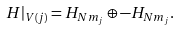<formula> <loc_0><loc_0><loc_500><loc_500>H | _ { V ( j ) } = H _ { N m _ { j } } \oplus - H _ { N m _ { j } } .</formula> 